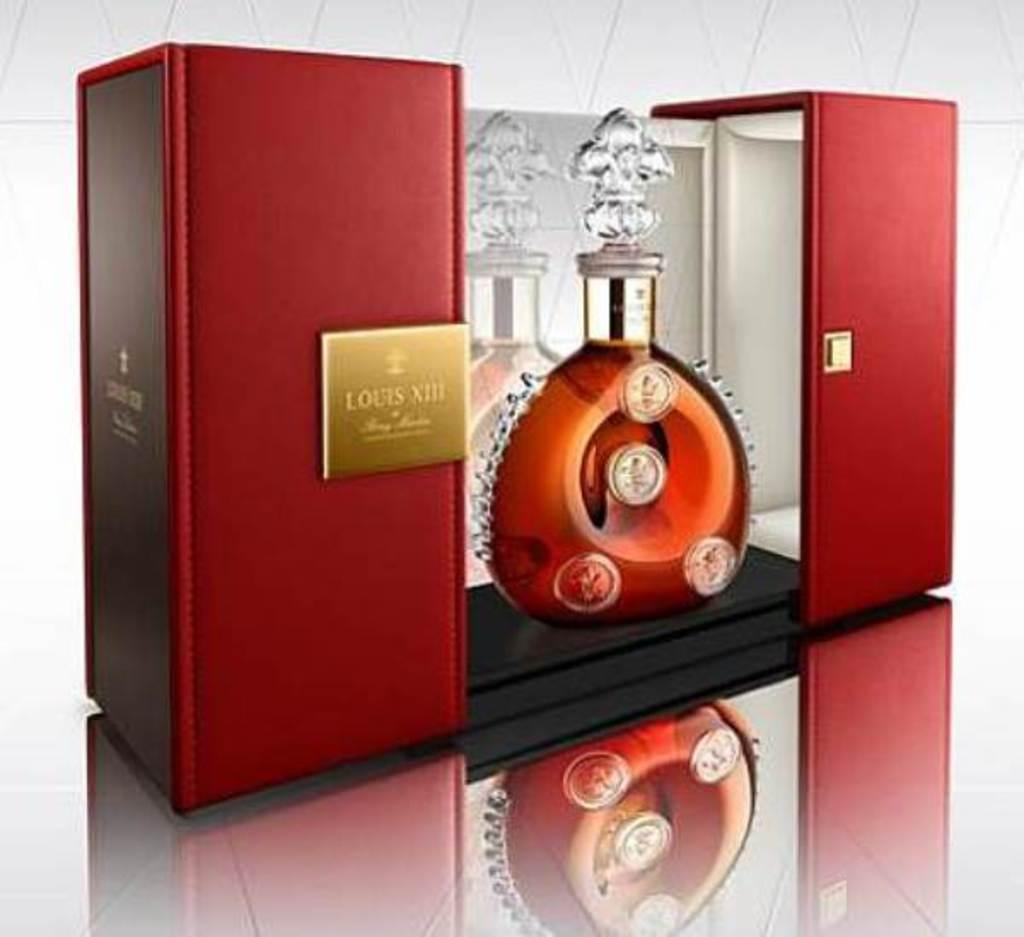<image>
Summarize the visual content of the image. Box of an alcohol bottle that says "Louis" on it. 